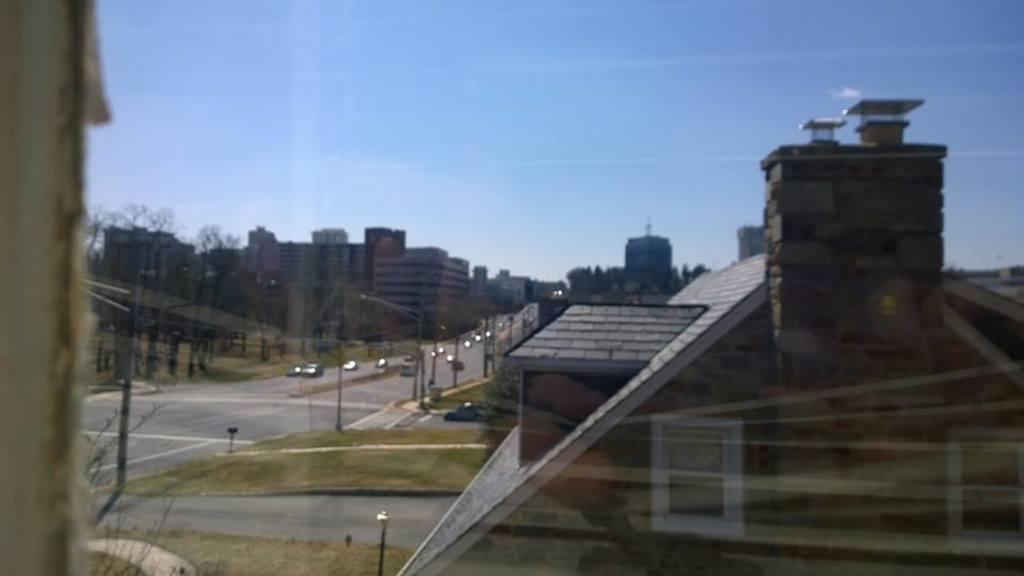What is the medium through which the image is taken? The image is taken through a glass. What type of structures can be seen in the image? There are buildings visible in the image. What is the transportation infrastructure in the image? There is a road in the image, and vehicles are moving on it. What are the vertical structures in the image? There are poles in the image. What type of natural elements are present in the image? Trees are present in the image. What part of the environment is visible in the image? The sky is visible in the image. What type of mask is being worn by the trees in the image? There are no masks present in the image, as it features buildings, a road, vehicles, poles, trees, and the sky. How much credit is available on the vehicles in the image? There is no mention of credit or any financial aspect related to the vehicles in the image. 